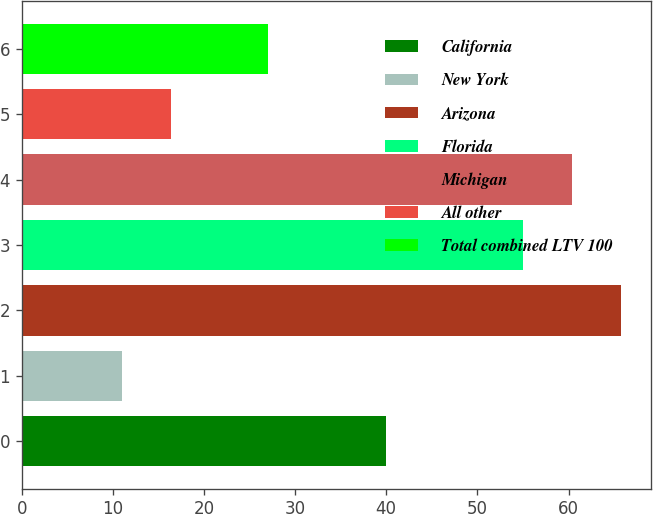Convert chart. <chart><loc_0><loc_0><loc_500><loc_500><bar_chart><fcel>California<fcel>New York<fcel>Arizona<fcel>Florida<fcel>Michigan<fcel>All other<fcel>Total combined LTV 100<nl><fcel>40<fcel>11<fcel>65.8<fcel>55<fcel>60.4<fcel>16.4<fcel>27<nl></chart> 